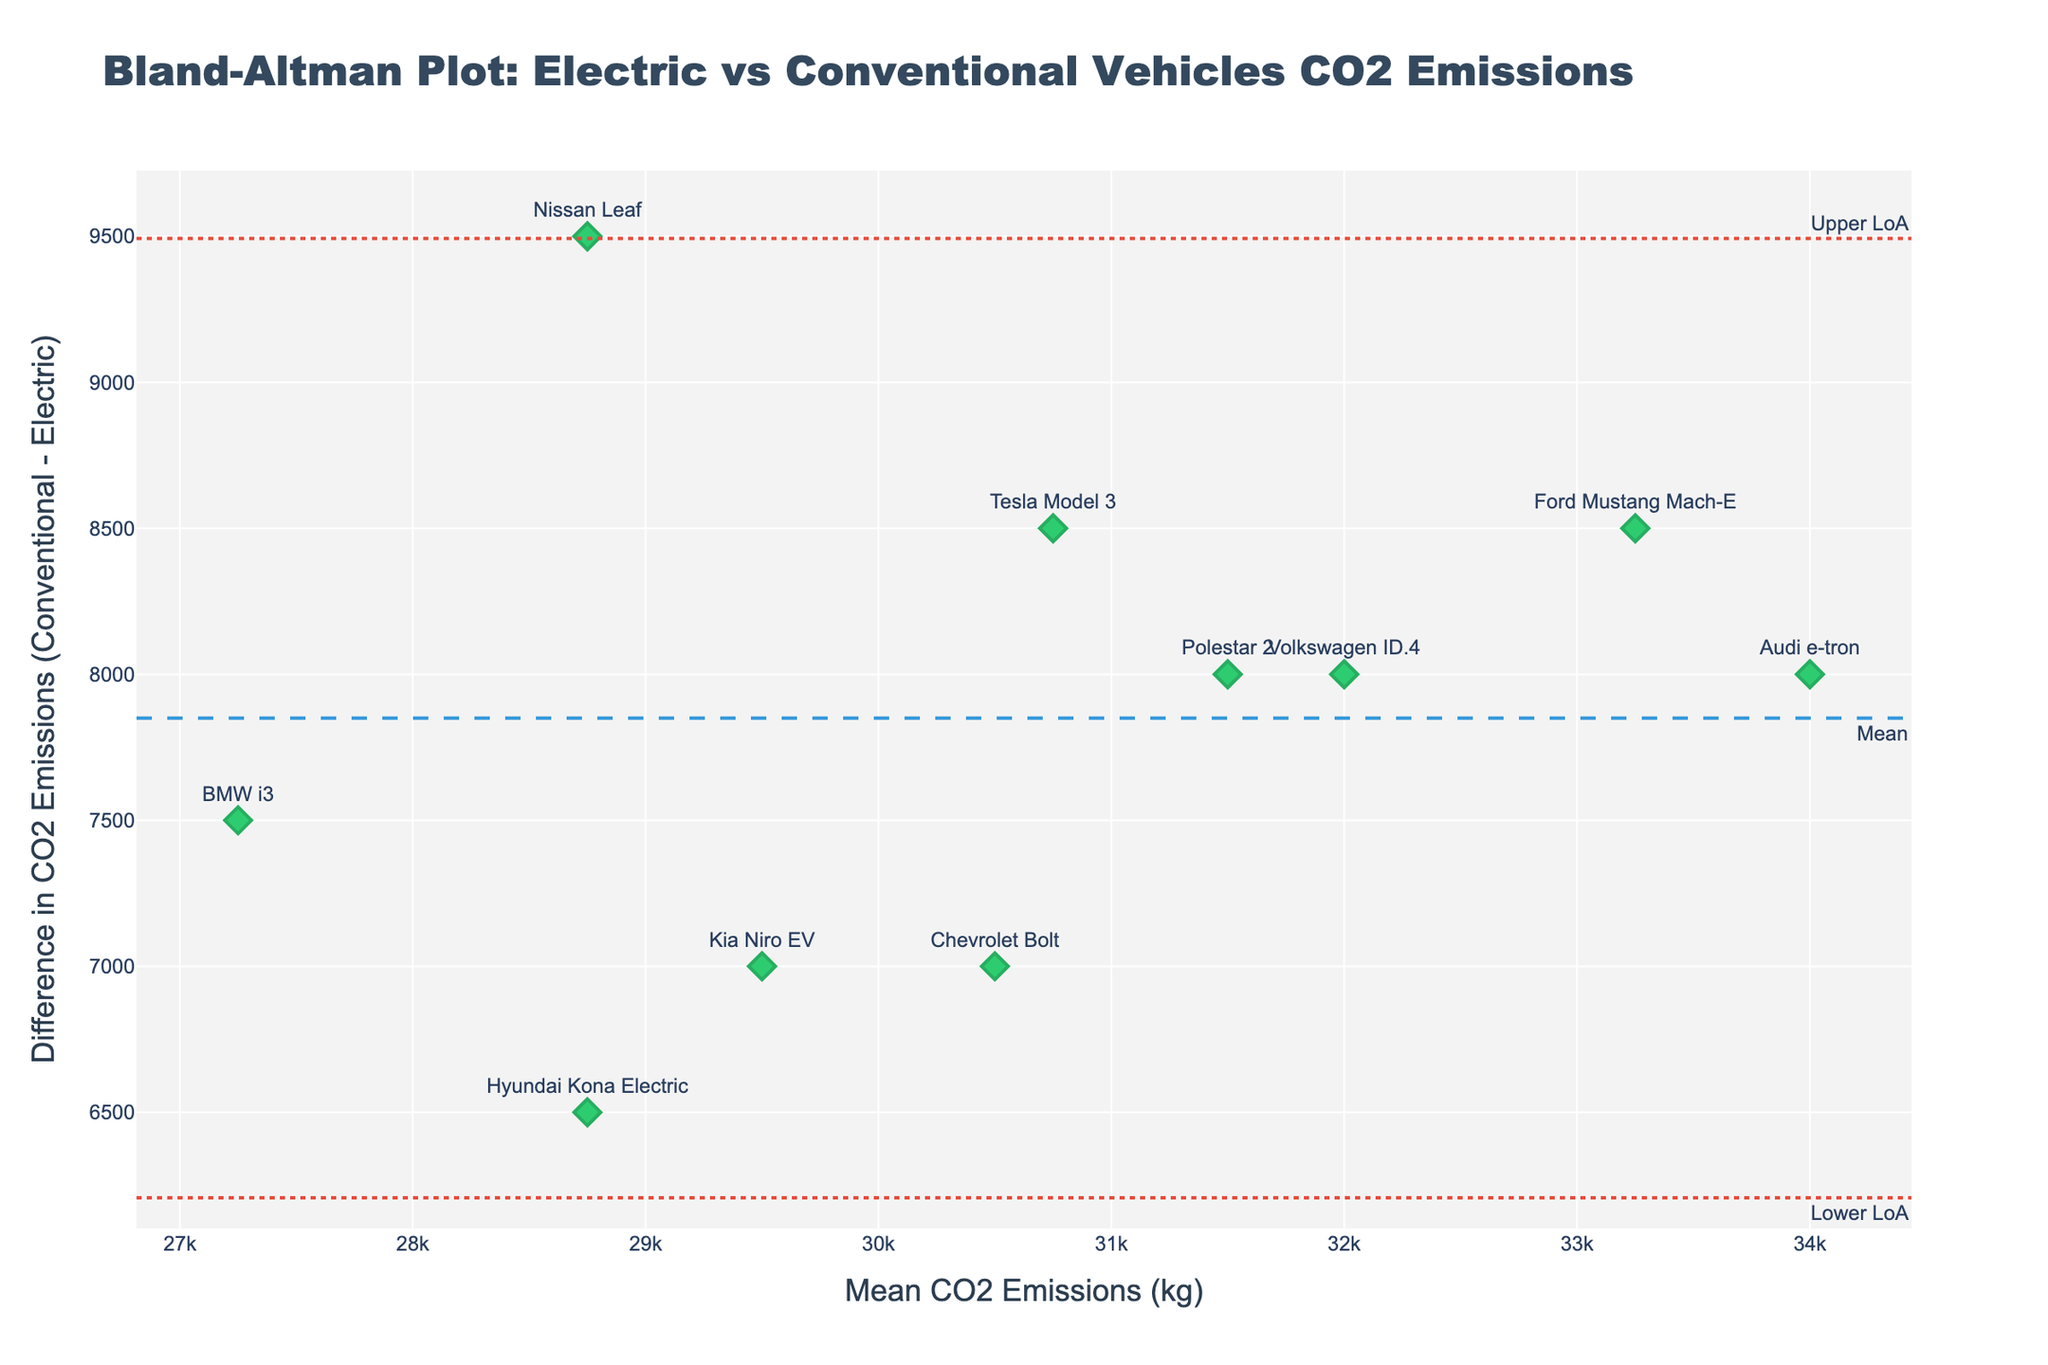What does the title of the plot indicate? The title of the plot reads "Bland-Altman Plot: Electric vs Conventional Vehicles CO2 Emissions," indicating that it visually compares the carbon dioxide emissions between electric and conventional vehicles.
Answer: The title indicates a comparison of CO2 emissions between electric and conventional vehicles What is represented on the x-axis of the plot? The x-axis is labeled "Mean CO2 Emissions (kg)," which shows the average carbon dioxide emissions of both vehicle types for each data point.
Answer: Mean CO2 emissions (kg) What color and symbol represent the data points in the plot? The data points are represented by green diamonds, with an outline color slightly darker green.
Answer: Green diamonds What is the mean difference in CO2 emissions, according to the plot? The mean difference in CO2 emissions is represented by the dashed line labeled "Mean." From the plot, it's positioned around a specific y-value corresponding to the mean difference.
Answer: Mean difference in CO2 emissions Which car models have the largest and smallest differences in CO2 emissions? By observing the vertical distances from the mean line, the Ford Mustang Mach-E has the largest difference (highest point) and the BMW i3 has the smallest difference (lowest point).
Answer: Ford Mustang Mach-E, BMW i3 What are the upper and lower limits of agreement (LoA) in CO2 emissions differences, according to the plot? The plot includes two dotted lines labeled "Upper LoA" and "Lower LoA," indicating the range within which most differences fall, calculated as the mean difference ± 1.96 times the standard deviation.
Answer: Upper and lower LoA in CO2 emissions differences How many data points are represented in the plot? Each vehicle model corresponds to one data point. By counting the labeled models, there are 10 data points.
Answer: 10 Calculate and compare the average CO2 emissions of the models with the highest and lowest differences. The info for the highest (Ford Mustang Mach-E) and lowest (BMW i3) is provided. Average CO2 emissions for Ford Mustang Mach-E are (29000+37500)/2 = 33250. Average CO2 emissions for BMW i3 are (23500+31000)/2 = 27250. The difference between these averages is 33250 - 27250 = 6000 kg.
Answer: 6000 kg Which model falls closest to the mean line of CO2 emissions differences? The data point closest to the mean line is the one with the smallest vertical distance from the dashed line labeled "Mean." This model appears to be the BMW i3.
Answer: BMW i3 